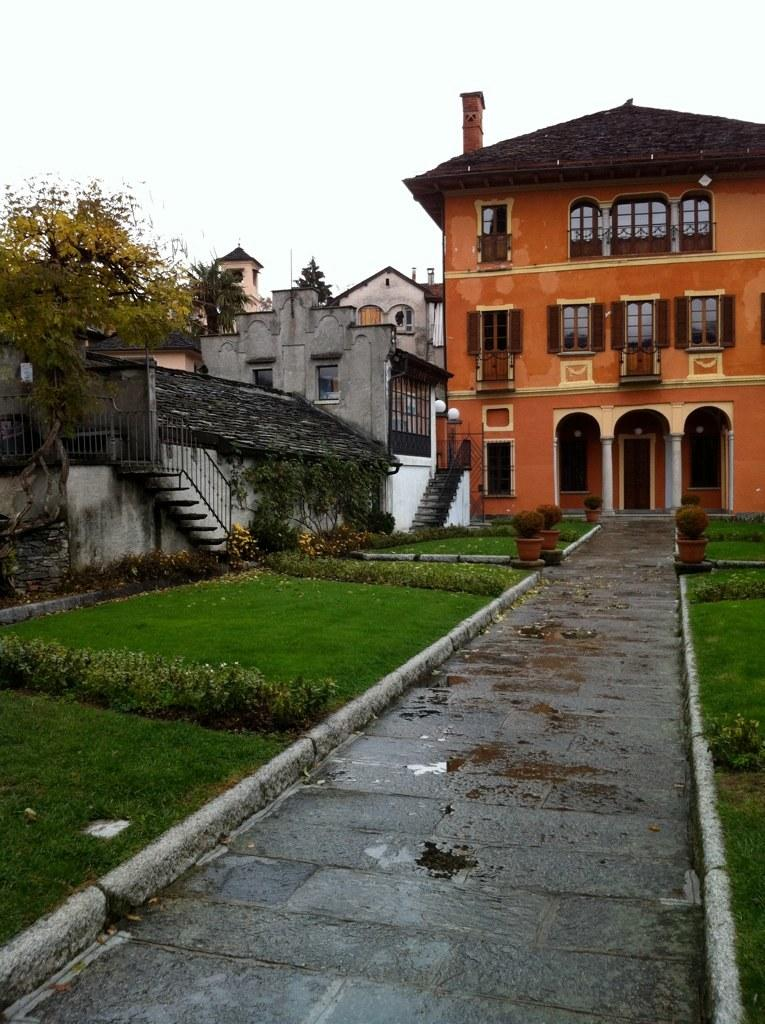What type of vegetation can be seen in the image? There is grass and plants in the image. Are there any architectural features present in the image? Yes, there are stairs and buildings in the image. What other natural element is visible in the image? There is a tree in the image. What part of the natural environment is visible in the image? The sky is visible in the image. What level of difficulty is the attraction in the image designed for? There is no attraction present in the image; it features grass, plants, stairs, buildings, a tree, and the sky. Are there any slaves depicted in the image? There are no slaves or any indication of slavery in the image. 